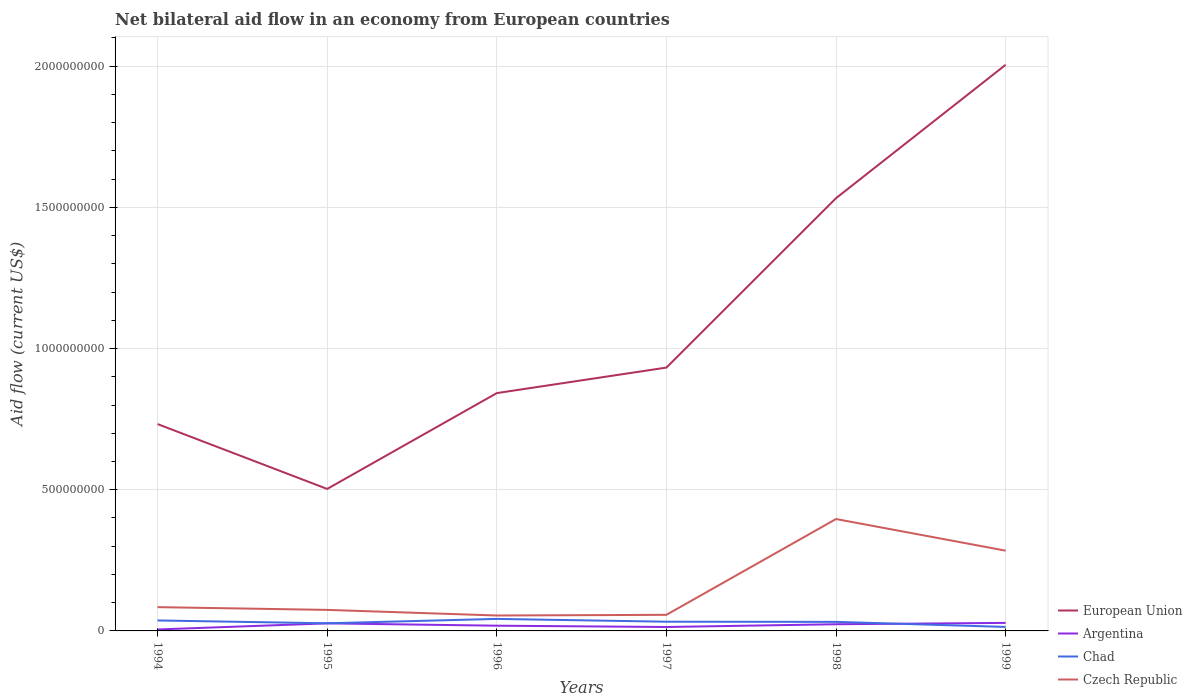How many different coloured lines are there?
Give a very brief answer. 4. Does the line corresponding to European Union intersect with the line corresponding to Czech Republic?
Give a very brief answer. No. Across all years, what is the maximum net bilateral aid flow in Argentina?
Give a very brief answer. 5.17e+06. In which year was the net bilateral aid flow in Czech Republic maximum?
Provide a succinct answer. 1996. What is the total net bilateral aid flow in Chad in the graph?
Keep it short and to the point. 9.90e+06. What is the difference between the highest and the second highest net bilateral aid flow in European Union?
Your answer should be compact. 1.50e+09. How many lines are there?
Ensure brevity in your answer.  4. What is the difference between two consecutive major ticks on the Y-axis?
Provide a succinct answer. 5.00e+08. Does the graph contain grids?
Give a very brief answer. Yes. How many legend labels are there?
Provide a succinct answer. 4. How are the legend labels stacked?
Your response must be concise. Vertical. What is the title of the graph?
Provide a short and direct response. Net bilateral aid flow in an economy from European countries. What is the label or title of the Y-axis?
Your answer should be compact. Aid flow (current US$). What is the Aid flow (current US$) in European Union in 1994?
Your response must be concise. 7.33e+08. What is the Aid flow (current US$) in Argentina in 1994?
Offer a very short reply. 5.17e+06. What is the Aid flow (current US$) of Chad in 1994?
Make the answer very short. 3.71e+07. What is the Aid flow (current US$) of Czech Republic in 1994?
Provide a short and direct response. 8.42e+07. What is the Aid flow (current US$) of European Union in 1995?
Offer a very short reply. 5.03e+08. What is the Aid flow (current US$) in Argentina in 1995?
Provide a short and direct response. 2.68e+07. What is the Aid flow (current US$) of Chad in 1995?
Your response must be concise. 2.70e+07. What is the Aid flow (current US$) of Czech Republic in 1995?
Provide a succinct answer. 7.45e+07. What is the Aid flow (current US$) in European Union in 1996?
Offer a very short reply. 8.42e+08. What is the Aid flow (current US$) in Argentina in 1996?
Your answer should be very brief. 1.85e+07. What is the Aid flow (current US$) of Chad in 1996?
Your response must be concise. 4.26e+07. What is the Aid flow (current US$) of Czech Republic in 1996?
Provide a short and direct response. 5.46e+07. What is the Aid flow (current US$) in European Union in 1997?
Provide a short and direct response. 9.33e+08. What is the Aid flow (current US$) of Argentina in 1997?
Your answer should be compact. 1.39e+07. What is the Aid flow (current US$) in Chad in 1997?
Offer a very short reply. 3.27e+07. What is the Aid flow (current US$) in Czech Republic in 1997?
Provide a succinct answer. 5.70e+07. What is the Aid flow (current US$) in European Union in 1998?
Your response must be concise. 1.53e+09. What is the Aid flow (current US$) of Argentina in 1998?
Offer a terse response. 2.37e+07. What is the Aid flow (current US$) of Chad in 1998?
Your answer should be compact. 3.21e+07. What is the Aid flow (current US$) in Czech Republic in 1998?
Give a very brief answer. 3.96e+08. What is the Aid flow (current US$) of European Union in 1999?
Offer a terse response. 2.01e+09. What is the Aid flow (current US$) of Argentina in 1999?
Make the answer very short. 2.84e+07. What is the Aid flow (current US$) in Chad in 1999?
Your answer should be very brief. 1.42e+07. What is the Aid flow (current US$) of Czech Republic in 1999?
Provide a short and direct response. 2.84e+08. Across all years, what is the maximum Aid flow (current US$) in European Union?
Give a very brief answer. 2.01e+09. Across all years, what is the maximum Aid flow (current US$) of Argentina?
Give a very brief answer. 2.84e+07. Across all years, what is the maximum Aid flow (current US$) in Chad?
Your answer should be compact. 4.26e+07. Across all years, what is the maximum Aid flow (current US$) in Czech Republic?
Your response must be concise. 3.96e+08. Across all years, what is the minimum Aid flow (current US$) in European Union?
Ensure brevity in your answer.  5.03e+08. Across all years, what is the minimum Aid flow (current US$) of Argentina?
Your response must be concise. 5.17e+06. Across all years, what is the minimum Aid flow (current US$) in Chad?
Provide a short and direct response. 1.42e+07. Across all years, what is the minimum Aid flow (current US$) in Czech Republic?
Offer a terse response. 5.46e+07. What is the total Aid flow (current US$) in European Union in the graph?
Offer a terse response. 6.55e+09. What is the total Aid flow (current US$) in Argentina in the graph?
Your answer should be compact. 1.16e+08. What is the total Aid flow (current US$) of Chad in the graph?
Your answer should be compact. 1.86e+08. What is the total Aid flow (current US$) in Czech Republic in the graph?
Provide a succinct answer. 9.51e+08. What is the difference between the Aid flow (current US$) of European Union in 1994 and that in 1995?
Provide a short and direct response. 2.30e+08. What is the difference between the Aid flow (current US$) of Argentina in 1994 and that in 1995?
Offer a very short reply. -2.16e+07. What is the difference between the Aid flow (current US$) in Chad in 1994 and that in 1995?
Give a very brief answer. 1.01e+07. What is the difference between the Aid flow (current US$) of Czech Republic in 1994 and that in 1995?
Provide a succinct answer. 9.75e+06. What is the difference between the Aid flow (current US$) in European Union in 1994 and that in 1996?
Ensure brevity in your answer.  -1.10e+08. What is the difference between the Aid flow (current US$) in Argentina in 1994 and that in 1996?
Ensure brevity in your answer.  -1.33e+07. What is the difference between the Aid flow (current US$) of Chad in 1994 and that in 1996?
Offer a very short reply. -5.50e+06. What is the difference between the Aid flow (current US$) in Czech Republic in 1994 and that in 1996?
Provide a short and direct response. 2.96e+07. What is the difference between the Aid flow (current US$) in European Union in 1994 and that in 1997?
Provide a short and direct response. -2.00e+08. What is the difference between the Aid flow (current US$) in Argentina in 1994 and that in 1997?
Provide a succinct answer. -8.72e+06. What is the difference between the Aid flow (current US$) of Chad in 1994 and that in 1997?
Keep it short and to the point. 4.40e+06. What is the difference between the Aid flow (current US$) in Czech Republic in 1994 and that in 1997?
Keep it short and to the point. 2.72e+07. What is the difference between the Aid flow (current US$) in European Union in 1994 and that in 1998?
Ensure brevity in your answer.  -8.00e+08. What is the difference between the Aid flow (current US$) of Argentina in 1994 and that in 1998?
Your response must be concise. -1.85e+07. What is the difference between the Aid flow (current US$) of Chad in 1994 and that in 1998?
Give a very brief answer. 5.01e+06. What is the difference between the Aid flow (current US$) of Czech Republic in 1994 and that in 1998?
Offer a very short reply. -3.12e+08. What is the difference between the Aid flow (current US$) of European Union in 1994 and that in 1999?
Keep it short and to the point. -1.27e+09. What is the difference between the Aid flow (current US$) of Argentina in 1994 and that in 1999?
Offer a terse response. -2.33e+07. What is the difference between the Aid flow (current US$) in Chad in 1994 and that in 1999?
Offer a terse response. 2.29e+07. What is the difference between the Aid flow (current US$) in Czech Republic in 1994 and that in 1999?
Make the answer very short. -2.00e+08. What is the difference between the Aid flow (current US$) of European Union in 1995 and that in 1996?
Provide a succinct answer. -3.39e+08. What is the difference between the Aid flow (current US$) in Argentina in 1995 and that in 1996?
Make the answer very short. 8.29e+06. What is the difference between the Aid flow (current US$) in Chad in 1995 and that in 1996?
Give a very brief answer. -1.56e+07. What is the difference between the Aid flow (current US$) in Czech Republic in 1995 and that in 1996?
Provide a short and direct response. 1.99e+07. What is the difference between the Aid flow (current US$) in European Union in 1995 and that in 1997?
Provide a succinct answer. -4.30e+08. What is the difference between the Aid flow (current US$) in Argentina in 1995 and that in 1997?
Your response must be concise. 1.29e+07. What is the difference between the Aid flow (current US$) in Chad in 1995 and that in 1997?
Your response must be concise. -5.67e+06. What is the difference between the Aid flow (current US$) of Czech Republic in 1995 and that in 1997?
Provide a short and direct response. 1.75e+07. What is the difference between the Aid flow (current US$) of European Union in 1995 and that in 1998?
Ensure brevity in your answer.  -1.03e+09. What is the difference between the Aid flow (current US$) of Argentina in 1995 and that in 1998?
Your answer should be compact. 3.12e+06. What is the difference between the Aid flow (current US$) of Chad in 1995 and that in 1998?
Give a very brief answer. -5.06e+06. What is the difference between the Aid flow (current US$) of Czech Republic in 1995 and that in 1998?
Provide a short and direct response. -3.22e+08. What is the difference between the Aid flow (current US$) in European Union in 1995 and that in 1999?
Provide a short and direct response. -1.50e+09. What is the difference between the Aid flow (current US$) in Argentina in 1995 and that in 1999?
Provide a short and direct response. -1.63e+06. What is the difference between the Aid flow (current US$) of Chad in 1995 and that in 1999?
Your answer should be very brief. 1.28e+07. What is the difference between the Aid flow (current US$) of Czech Republic in 1995 and that in 1999?
Offer a terse response. -2.10e+08. What is the difference between the Aid flow (current US$) of European Union in 1996 and that in 1997?
Make the answer very short. -9.04e+07. What is the difference between the Aid flow (current US$) in Argentina in 1996 and that in 1997?
Provide a succinct answer. 4.62e+06. What is the difference between the Aid flow (current US$) of Chad in 1996 and that in 1997?
Your response must be concise. 9.90e+06. What is the difference between the Aid flow (current US$) of Czech Republic in 1996 and that in 1997?
Give a very brief answer. -2.37e+06. What is the difference between the Aid flow (current US$) in European Union in 1996 and that in 1998?
Your response must be concise. -6.90e+08. What is the difference between the Aid flow (current US$) of Argentina in 1996 and that in 1998?
Offer a terse response. -5.17e+06. What is the difference between the Aid flow (current US$) of Chad in 1996 and that in 1998?
Your answer should be compact. 1.05e+07. What is the difference between the Aid flow (current US$) in Czech Republic in 1996 and that in 1998?
Your response must be concise. -3.42e+08. What is the difference between the Aid flow (current US$) in European Union in 1996 and that in 1999?
Your response must be concise. -1.16e+09. What is the difference between the Aid flow (current US$) of Argentina in 1996 and that in 1999?
Ensure brevity in your answer.  -9.92e+06. What is the difference between the Aid flow (current US$) in Chad in 1996 and that in 1999?
Your answer should be very brief. 2.84e+07. What is the difference between the Aid flow (current US$) in Czech Republic in 1996 and that in 1999?
Offer a terse response. -2.30e+08. What is the difference between the Aid flow (current US$) in European Union in 1997 and that in 1998?
Your response must be concise. -6.00e+08. What is the difference between the Aid flow (current US$) of Argentina in 1997 and that in 1998?
Keep it short and to the point. -9.79e+06. What is the difference between the Aid flow (current US$) in Chad in 1997 and that in 1998?
Ensure brevity in your answer.  6.10e+05. What is the difference between the Aid flow (current US$) of Czech Republic in 1997 and that in 1998?
Your response must be concise. -3.39e+08. What is the difference between the Aid flow (current US$) of European Union in 1997 and that in 1999?
Make the answer very short. -1.07e+09. What is the difference between the Aid flow (current US$) of Argentina in 1997 and that in 1999?
Ensure brevity in your answer.  -1.45e+07. What is the difference between the Aid flow (current US$) in Chad in 1997 and that in 1999?
Keep it short and to the point. 1.85e+07. What is the difference between the Aid flow (current US$) in Czech Republic in 1997 and that in 1999?
Give a very brief answer. -2.27e+08. What is the difference between the Aid flow (current US$) in European Union in 1998 and that in 1999?
Give a very brief answer. -4.72e+08. What is the difference between the Aid flow (current US$) in Argentina in 1998 and that in 1999?
Make the answer very short. -4.75e+06. What is the difference between the Aid flow (current US$) of Chad in 1998 and that in 1999?
Offer a very short reply. 1.79e+07. What is the difference between the Aid flow (current US$) of Czech Republic in 1998 and that in 1999?
Ensure brevity in your answer.  1.12e+08. What is the difference between the Aid flow (current US$) of European Union in 1994 and the Aid flow (current US$) of Argentina in 1995?
Offer a terse response. 7.06e+08. What is the difference between the Aid flow (current US$) of European Union in 1994 and the Aid flow (current US$) of Chad in 1995?
Provide a short and direct response. 7.06e+08. What is the difference between the Aid flow (current US$) in European Union in 1994 and the Aid flow (current US$) in Czech Republic in 1995?
Your answer should be compact. 6.58e+08. What is the difference between the Aid flow (current US$) in Argentina in 1994 and the Aid flow (current US$) in Chad in 1995?
Provide a succinct answer. -2.18e+07. What is the difference between the Aid flow (current US$) of Argentina in 1994 and the Aid flow (current US$) of Czech Republic in 1995?
Offer a very short reply. -6.93e+07. What is the difference between the Aid flow (current US$) of Chad in 1994 and the Aid flow (current US$) of Czech Republic in 1995?
Your response must be concise. -3.74e+07. What is the difference between the Aid flow (current US$) in European Union in 1994 and the Aid flow (current US$) in Argentina in 1996?
Ensure brevity in your answer.  7.14e+08. What is the difference between the Aid flow (current US$) of European Union in 1994 and the Aid flow (current US$) of Chad in 1996?
Ensure brevity in your answer.  6.90e+08. What is the difference between the Aid flow (current US$) of European Union in 1994 and the Aid flow (current US$) of Czech Republic in 1996?
Give a very brief answer. 6.78e+08. What is the difference between the Aid flow (current US$) of Argentina in 1994 and the Aid flow (current US$) of Chad in 1996?
Provide a short and direct response. -3.74e+07. What is the difference between the Aid flow (current US$) of Argentina in 1994 and the Aid flow (current US$) of Czech Republic in 1996?
Keep it short and to the point. -4.94e+07. What is the difference between the Aid flow (current US$) of Chad in 1994 and the Aid flow (current US$) of Czech Republic in 1996?
Make the answer very short. -1.76e+07. What is the difference between the Aid flow (current US$) of European Union in 1994 and the Aid flow (current US$) of Argentina in 1997?
Provide a short and direct response. 7.19e+08. What is the difference between the Aid flow (current US$) of European Union in 1994 and the Aid flow (current US$) of Chad in 1997?
Give a very brief answer. 7.00e+08. What is the difference between the Aid flow (current US$) of European Union in 1994 and the Aid flow (current US$) of Czech Republic in 1997?
Give a very brief answer. 6.76e+08. What is the difference between the Aid flow (current US$) of Argentina in 1994 and the Aid flow (current US$) of Chad in 1997?
Provide a short and direct response. -2.75e+07. What is the difference between the Aid flow (current US$) in Argentina in 1994 and the Aid flow (current US$) in Czech Republic in 1997?
Your response must be concise. -5.18e+07. What is the difference between the Aid flow (current US$) in Chad in 1994 and the Aid flow (current US$) in Czech Republic in 1997?
Give a very brief answer. -1.99e+07. What is the difference between the Aid flow (current US$) in European Union in 1994 and the Aid flow (current US$) in Argentina in 1998?
Your answer should be compact. 7.09e+08. What is the difference between the Aid flow (current US$) of European Union in 1994 and the Aid flow (current US$) of Chad in 1998?
Your response must be concise. 7.01e+08. What is the difference between the Aid flow (current US$) of European Union in 1994 and the Aid flow (current US$) of Czech Republic in 1998?
Your answer should be compact. 3.36e+08. What is the difference between the Aid flow (current US$) in Argentina in 1994 and the Aid flow (current US$) in Chad in 1998?
Offer a terse response. -2.69e+07. What is the difference between the Aid flow (current US$) in Argentina in 1994 and the Aid flow (current US$) in Czech Republic in 1998?
Offer a very short reply. -3.91e+08. What is the difference between the Aid flow (current US$) in Chad in 1994 and the Aid flow (current US$) in Czech Republic in 1998?
Give a very brief answer. -3.59e+08. What is the difference between the Aid flow (current US$) of European Union in 1994 and the Aid flow (current US$) of Argentina in 1999?
Give a very brief answer. 7.04e+08. What is the difference between the Aid flow (current US$) in European Union in 1994 and the Aid flow (current US$) in Chad in 1999?
Give a very brief answer. 7.18e+08. What is the difference between the Aid flow (current US$) in European Union in 1994 and the Aid flow (current US$) in Czech Republic in 1999?
Ensure brevity in your answer.  4.48e+08. What is the difference between the Aid flow (current US$) of Argentina in 1994 and the Aid flow (current US$) of Chad in 1999?
Your answer should be compact. -8.98e+06. What is the difference between the Aid flow (current US$) in Argentina in 1994 and the Aid flow (current US$) in Czech Republic in 1999?
Offer a terse response. -2.79e+08. What is the difference between the Aid flow (current US$) of Chad in 1994 and the Aid flow (current US$) of Czech Republic in 1999?
Offer a very short reply. -2.47e+08. What is the difference between the Aid flow (current US$) in European Union in 1995 and the Aid flow (current US$) in Argentina in 1996?
Provide a short and direct response. 4.84e+08. What is the difference between the Aid flow (current US$) of European Union in 1995 and the Aid flow (current US$) of Chad in 1996?
Your answer should be very brief. 4.60e+08. What is the difference between the Aid flow (current US$) of European Union in 1995 and the Aid flow (current US$) of Czech Republic in 1996?
Offer a terse response. 4.48e+08. What is the difference between the Aid flow (current US$) in Argentina in 1995 and the Aid flow (current US$) in Chad in 1996?
Provide a short and direct response. -1.58e+07. What is the difference between the Aid flow (current US$) in Argentina in 1995 and the Aid flow (current US$) in Czech Republic in 1996?
Your answer should be very brief. -2.78e+07. What is the difference between the Aid flow (current US$) in Chad in 1995 and the Aid flow (current US$) in Czech Republic in 1996?
Give a very brief answer. -2.76e+07. What is the difference between the Aid flow (current US$) of European Union in 1995 and the Aid flow (current US$) of Argentina in 1997?
Provide a short and direct response. 4.89e+08. What is the difference between the Aid flow (current US$) in European Union in 1995 and the Aid flow (current US$) in Chad in 1997?
Provide a short and direct response. 4.70e+08. What is the difference between the Aid flow (current US$) in European Union in 1995 and the Aid flow (current US$) in Czech Republic in 1997?
Your response must be concise. 4.46e+08. What is the difference between the Aid flow (current US$) in Argentina in 1995 and the Aid flow (current US$) in Chad in 1997?
Your answer should be very brief. -5.87e+06. What is the difference between the Aid flow (current US$) of Argentina in 1995 and the Aid flow (current US$) of Czech Republic in 1997?
Your answer should be very brief. -3.02e+07. What is the difference between the Aid flow (current US$) in Chad in 1995 and the Aid flow (current US$) in Czech Republic in 1997?
Your answer should be compact. -3.00e+07. What is the difference between the Aid flow (current US$) in European Union in 1995 and the Aid flow (current US$) in Argentina in 1998?
Make the answer very short. 4.79e+08. What is the difference between the Aid flow (current US$) of European Union in 1995 and the Aid flow (current US$) of Chad in 1998?
Your answer should be very brief. 4.71e+08. What is the difference between the Aid flow (current US$) of European Union in 1995 and the Aid flow (current US$) of Czech Republic in 1998?
Provide a succinct answer. 1.07e+08. What is the difference between the Aid flow (current US$) in Argentina in 1995 and the Aid flow (current US$) in Chad in 1998?
Make the answer very short. -5.26e+06. What is the difference between the Aid flow (current US$) in Argentina in 1995 and the Aid flow (current US$) in Czech Republic in 1998?
Provide a short and direct response. -3.69e+08. What is the difference between the Aid flow (current US$) of Chad in 1995 and the Aid flow (current US$) of Czech Republic in 1998?
Offer a terse response. -3.69e+08. What is the difference between the Aid flow (current US$) of European Union in 1995 and the Aid flow (current US$) of Argentina in 1999?
Make the answer very short. 4.74e+08. What is the difference between the Aid flow (current US$) of European Union in 1995 and the Aid flow (current US$) of Chad in 1999?
Your answer should be compact. 4.89e+08. What is the difference between the Aid flow (current US$) in European Union in 1995 and the Aid flow (current US$) in Czech Republic in 1999?
Keep it short and to the point. 2.19e+08. What is the difference between the Aid flow (current US$) in Argentina in 1995 and the Aid flow (current US$) in Chad in 1999?
Provide a short and direct response. 1.26e+07. What is the difference between the Aid flow (current US$) of Argentina in 1995 and the Aid flow (current US$) of Czech Republic in 1999?
Your answer should be very brief. -2.57e+08. What is the difference between the Aid flow (current US$) of Chad in 1995 and the Aid flow (current US$) of Czech Republic in 1999?
Give a very brief answer. -2.57e+08. What is the difference between the Aid flow (current US$) in European Union in 1996 and the Aid flow (current US$) in Argentina in 1997?
Give a very brief answer. 8.28e+08. What is the difference between the Aid flow (current US$) in European Union in 1996 and the Aid flow (current US$) in Chad in 1997?
Your answer should be compact. 8.10e+08. What is the difference between the Aid flow (current US$) in European Union in 1996 and the Aid flow (current US$) in Czech Republic in 1997?
Offer a very short reply. 7.85e+08. What is the difference between the Aid flow (current US$) in Argentina in 1996 and the Aid flow (current US$) in Chad in 1997?
Ensure brevity in your answer.  -1.42e+07. What is the difference between the Aid flow (current US$) in Argentina in 1996 and the Aid flow (current US$) in Czech Republic in 1997?
Provide a short and direct response. -3.85e+07. What is the difference between the Aid flow (current US$) of Chad in 1996 and the Aid flow (current US$) of Czech Republic in 1997?
Your answer should be very brief. -1.44e+07. What is the difference between the Aid flow (current US$) of European Union in 1996 and the Aid flow (current US$) of Argentina in 1998?
Provide a succinct answer. 8.19e+08. What is the difference between the Aid flow (current US$) of European Union in 1996 and the Aid flow (current US$) of Chad in 1998?
Your answer should be compact. 8.10e+08. What is the difference between the Aid flow (current US$) of European Union in 1996 and the Aid flow (current US$) of Czech Republic in 1998?
Ensure brevity in your answer.  4.46e+08. What is the difference between the Aid flow (current US$) of Argentina in 1996 and the Aid flow (current US$) of Chad in 1998?
Your response must be concise. -1.36e+07. What is the difference between the Aid flow (current US$) of Argentina in 1996 and the Aid flow (current US$) of Czech Republic in 1998?
Ensure brevity in your answer.  -3.78e+08. What is the difference between the Aid flow (current US$) in Chad in 1996 and the Aid flow (current US$) in Czech Republic in 1998?
Offer a very short reply. -3.54e+08. What is the difference between the Aid flow (current US$) in European Union in 1996 and the Aid flow (current US$) in Argentina in 1999?
Keep it short and to the point. 8.14e+08. What is the difference between the Aid flow (current US$) in European Union in 1996 and the Aid flow (current US$) in Chad in 1999?
Keep it short and to the point. 8.28e+08. What is the difference between the Aid flow (current US$) in European Union in 1996 and the Aid flow (current US$) in Czech Republic in 1999?
Keep it short and to the point. 5.58e+08. What is the difference between the Aid flow (current US$) in Argentina in 1996 and the Aid flow (current US$) in Chad in 1999?
Give a very brief answer. 4.36e+06. What is the difference between the Aid flow (current US$) in Argentina in 1996 and the Aid flow (current US$) in Czech Republic in 1999?
Provide a short and direct response. -2.66e+08. What is the difference between the Aid flow (current US$) of Chad in 1996 and the Aid flow (current US$) of Czech Republic in 1999?
Make the answer very short. -2.42e+08. What is the difference between the Aid flow (current US$) of European Union in 1997 and the Aid flow (current US$) of Argentina in 1998?
Provide a succinct answer. 9.09e+08. What is the difference between the Aid flow (current US$) in European Union in 1997 and the Aid flow (current US$) in Chad in 1998?
Keep it short and to the point. 9.01e+08. What is the difference between the Aid flow (current US$) in European Union in 1997 and the Aid flow (current US$) in Czech Republic in 1998?
Your response must be concise. 5.36e+08. What is the difference between the Aid flow (current US$) in Argentina in 1997 and the Aid flow (current US$) in Chad in 1998?
Offer a terse response. -1.82e+07. What is the difference between the Aid flow (current US$) of Argentina in 1997 and the Aid flow (current US$) of Czech Republic in 1998?
Give a very brief answer. -3.82e+08. What is the difference between the Aid flow (current US$) in Chad in 1997 and the Aid flow (current US$) in Czech Republic in 1998?
Give a very brief answer. -3.64e+08. What is the difference between the Aid flow (current US$) in European Union in 1997 and the Aid flow (current US$) in Argentina in 1999?
Ensure brevity in your answer.  9.04e+08. What is the difference between the Aid flow (current US$) of European Union in 1997 and the Aid flow (current US$) of Chad in 1999?
Keep it short and to the point. 9.19e+08. What is the difference between the Aid flow (current US$) of European Union in 1997 and the Aid flow (current US$) of Czech Republic in 1999?
Offer a terse response. 6.48e+08. What is the difference between the Aid flow (current US$) in Argentina in 1997 and the Aid flow (current US$) in Czech Republic in 1999?
Keep it short and to the point. -2.70e+08. What is the difference between the Aid flow (current US$) in Chad in 1997 and the Aid flow (current US$) in Czech Republic in 1999?
Make the answer very short. -2.52e+08. What is the difference between the Aid flow (current US$) in European Union in 1998 and the Aid flow (current US$) in Argentina in 1999?
Ensure brevity in your answer.  1.50e+09. What is the difference between the Aid flow (current US$) of European Union in 1998 and the Aid flow (current US$) of Chad in 1999?
Provide a short and direct response. 1.52e+09. What is the difference between the Aid flow (current US$) in European Union in 1998 and the Aid flow (current US$) in Czech Republic in 1999?
Offer a very short reply. 1.25e+09. What is the difference between the Aid flow (current US$) in Argentina in 1998 and the Aid flow (current US$) in Chad in 1999?
Make the answer very short. 9.53e+06. What is the difference between the Aid flow (current US$) in Argentina in 1998 and the Aid flow (current US$) in Czech Republic in 1999?
Keep it short and to the point. -2.61e+08. What is the difference between the Aid flow (current US$) of Chad in 1998 and the Aid flow (current US$) of Czech Republic in 1999?
Provide a succinct answer. -2.52e+08. What is the average Aid flow (current US$) of European Union per year?
Ensure brevity in your answer.  1.09e+09. What is the average Aid flow (current US$) in Argentina per year?
Give a very brief answer. 1.94e+07. What is the average Aid flow (current US$) in Chad per year?
Make the answer very short. 3.09e+07. What is the average Aid flow (current US$) of Czech Republic per year?
Offer a terse response. 1.58e+08. In the year 1994, what is the difference between the Aid flow (current US$) in European Union and Aid flow (current US$) in Argentina?
Offer a terse response. 7.27e+08. In the year 1994, what is the difference between the Aid flow (current US$) in European Union and Aid flow (current US$) in Chad?
Offer a terse response. 6.96e+08. In the year 1994, what is the difference between the Aid flow (current US$) in European Union and Aid flow (current US$) in Czech Republic?
Ensure brevity in your answer.  6.48e+08. In the year 1994, what is the difference between the Aid flow (current US$) of Argentina and Aid flow (current US$) of Chad?
Give a very brief answer. -3.19e+07. In the year 1994, what is the difference between the Aid flow (current US$) of Argentina and Aid flow (current US$) of Czech Republic?
Provide a short and direct response. -7.91e+07. In the year 1994, what is the difference between the Aid flow (current US$) in Chad and Aid flow (current US$) in Czech Republic?
Offer a very short reply. -4.72e+07. In the year 1995, what is the difference between the Aid flow (current US$) in European Union and Aid flow (current US$) in Argentina?
Ensure brevity in your answer.  4.76e+08. In the year 1995, what is the difference between the Aid flow (current US$) of European Union and Aid flow (current US$) of Chad?
Ensure brevity in your answer.  4.76e+08. In the year 1995, what is the difference between the Aid flow (current US$) in European Union and Aid flow (current US$) in Czech Republic?
Offer a very short reply. 4.28e+08. In the year 1995, what is the difference between the Aid flow (current US$) in Argentina and Aid flow (current US$) in Czech Republic?
Offer a very short reply. -4.77e+07. In the year 1995, what is the difference between the Aid flow (current US$) in Chad and Aid flow (current US$) in Czech Republic?
Ensure brevity in your answer.  -4.75e+07. In the year 1996, what is the difference between the Aid flow (current US$) of European Union and Aid flow (current US$) of Argentina?
Offer a terse response. 8.24e+08. In the year 1996, what is the difference between the Aid flow (current US$) in European Union and Aid flow (current US$) in Chad?
Offer a very short reply. 8.00e+08. In the year 1996, what is the difference between the Aid flow (current US$) of European Union and Aid flow (current US$) of Czech Republic?
Keep it short and to the point. 7.88e+08. In the year 1996, what is the difference between the Aid flow (current US$) in Argentina and Aid flow (current US$) in Chad?
Provide a succinct answer. -2.41e+07. In the year 1996, what is the difference between the Aid flow (current US$) of Argentina and Aid flow (current US$) of Czech Republic?
Keep it short and to the point. -3.61e+07. In the year 1996, what is the difference between the Aid flow (current US$) in Chad and Aid flow (current US$) in Czech Republic?
Your response must be concise. -1.20e+07. In the year 1997, what is the difference between the Aid flow (current US$) of European Union and Aid flow (current US$) of Argentina?
Give a very brief answer. 9.19e+08. In the year 1997, what is the difference between the Aid flow (current US$) in European Union and Aid flow (current US$) in Chad?
Provide a succinct answer. 9.00e+08. In the year 1997, what is the difference between the Aid flow (current US$) in European Union and Aid flow (current US$) in Czech Republic?
Provide a short and direct response. 8.76e+08. In the year 1997, what is the difference between the Aid flow (current US$) of Argentina and Aid flow (current US$) of Chad?
Offer a very short reply. -1.88e+07. In the year 1997, what is the difference between the Aid flow (current US$) in Argentina and Aid flow (current US$) in Czech Republic?
Offer a very short reply. -4.31e+07. In the year 1997, what is the difference between the Aid flow (current US$) of Chad and Aid flow (current US$) of Czech Republic?
Your answer should be compact. -2.43e+07. In the year 1998, what is the difference between the Aid flow (current US$) of European Union and Aid flow (current US$) of Argentina?
Offer a terse response. 1.51e+09. In the year 1998, what is the difference between the Aid flow (current US$) in European Union and Aid flow (current US$) in Chad?
Ensure brevity in your answer.  1.50e+09. In the year 1998, what is the difference between the Aid flow (current US$) of European Union and Aid flow (current US$) of Czech Republic?
Your response must be concise. 1.14e+09. In the year 1998, what is the difference between the Aid flow (current US$) in Argentina and Aid flow (current US$) in Chad?
Provide a succinct answer. -8.38e+06. In the year 1998, what is the difference between the Aid flow (current US$) of Argentina and Aid flow (current US$) of Czech Republic?
Keep it short and to the point. -3.73e+08. In the year 1998, what is the difference between the Aid flow (current US$) in Chad and Aid flow (current US$) in Czech Republic?
Your response must be concise. -3.64e+08. In the year 1999, what is the difference between the Aid flow (current US$) of European Union and Aid flow (current US$) of Argentina?
Ensure brevity in your answer.  1.98e+09. In the year 1999, what is the difference between the Aid flow (current US$) of European Union and Aid flow (current US$) of Chad?
Offer a terse response. 1.99e+09. In the year 1999, what is the difference between the Aid flow (current US$) of European Union and Aid flow (current US$) of Czech Republic?
Your answer should be compact. 1.72e+09. In the year 1999, what is the difference between the Aid flow (current US$) in Argentina and Aid flow (current US$) in Chad?
Ensure brevity in your answer.  1.43e+07. In the year 1999, what is the difference between the Aid flow (current US$) of Argentina and Aid flow (current US$) of Czech Republic?
Your answer should be compact. -2.56e+08. In the year 1999, what is the difference between the Aid flow (current US$) of Chad and Aid flow (current US$) of Czech Republic?
Ensure brevity in your answer.  -2.70e+08. What is the ratio of the Aid flow (current US$) in European Union in 1994 to that in 1995?
Keep it short and to the point. 1.46. What is the ratio of the Aid flow (current US$) in Argentina in 1994 to that in 1995?
Ensure brevity in your answer.  0.19. What is the ratio of the Aid flow (current US$) in Chad in 1994 to that in 1995?
Keep it short and to the point. 1.37. What is the ratio of the Aid flow (current US$) of Czech Republic in 1994 to that in 1995?
Provide a succinct answer. 1.13. What is the ratio of the Aid flow (current US$) of European Union in 1994 to that in 1996?
Give a very brief answer. 0.87. What is the ratio of the Aid flow (current US$) of Argentina in 1994 to that in 1996?
Keep it short and to the point. 0.28. What is the ratio of the Aid flow (current US$) in Chad in 1994 to that in 1996?
Provide a short and direct response. 0.87. What is the ratio of the Aid flow (current US$) of Czech Republic in 1994 to that in 1996?
Offer a terse response. 1.54. What is the ratio of the Aid flow (current US$) in European Union in 1994 to that in 1997?
Offer a very short reply. 0.79. What is the ratio of the Aid flow (current US$) of Argentina in 1994 to that in 1997?
Keep it short and to the point. 0.37. What is the ratio of the Aid flow (current US$) in Chad in 1994 to that in 1997?
Keep it short and to the point. 1.13. What is the ratio of the Aid flow (current US$) of Czech Republic in 1994 to that in 1997?
Give a very brief answer. 1.48. What is the ratio of the Aid flow (current US$) of European Union in 1994 to that in 1998?
Your answer should be very brief. 0.48. What is the ratio of the Aid flow (current US$) of Argentina in 1994 to that in 1998?
Your response must be concise. 0.22. What is the ratio of the Aid flow (current US$) in Chad in 1994 to that in 1998?
Provide a succinct answer. 1.16. What is the ratio of the Aid flow (current US$) of Czech Republic in 1994 to that in 1998?
Provide a short and direct response. 0.21. What is the ratio of the Aid flow (current US$) in European Union in 1994 to that in 1999?
Provide a succinct answer. 0.37. What is the ratio of the Aid flow (current US$) in Argentina in 1994 to that in 1999?
Ensure brevity in your answer.  0.18. What is the ratio of the Aid flow (current US$) in Chad in 1994 to that in 1999?
Your response must be concise. 2.62. What is the ratio of the Aid flow (current US$) in Czech Republic in 1994 to that in 1999?
Keep it short and to the point. 0.3. What is the ratio of the Aid flow (current US$) of European Union in 1995 to that in 1996?
Provide a short and direct response. 0.6. What is the ratio of the Aid flow (current US$) in Argentina in 1995 to that in 1996?
Your response must be concise. 1.45. What is the ratio of the Aid flow (current US$) of Chad in 1995 to that in 1996?
Offer a very short reply. 0.63. What is the ratio of the Aid flow (current US$) in Czech Republic in 1995 to that in 1996?
Offer a very short reply. 1.36. What is the ratio of the Aid flow (current US$) of European Union in 1995 to that in 1997?
Offer a very short reply. 0.54. What is the ratio of the Aid flow (current US$) of Argentina in 1995 to that in 1997?
Keep it short and to the point. 1.93. What is the ratio of the Aid flow (current US$) of Chad in 1995 to that in 1997?
Keep it short and to the point. 0.83. What is the ratio of the Aid flow (current US$) of Czech Republic in 1995 to that in 1997?
Provide a short and direct response. 1.31. What is the ratio of the Aid flow (current US$) of European Union in 1995 to that in 1998?
Offer a terse response. 0.33. What is the ratio of the Aid flow (current US$) in Argentina in 1995 to that in 1998?
Give a very brief answer. 1.13. What is the ratio of the Aid flow (current US$) of Chad in 1995 to that in 1998?
Provide a succinct answer. 0.84. What is the ratio of the Aid flow (current US$) in Czech Republic in 1995 to that in 1998?
Your answer should be very brief. 0.19. What is the ratio of the Aid flow (current US$) in European Union in 1995 to that in 1999?
Give a very brief answer. 0.25. What is the ratio of the Aid flow (current US$) in Argentina in 1995 to that in 1999?
Ensure brevity in your answer.  0.94. What is the ratio of the Aid flow (current US$) of Chad in 1995 to that in 1999?
Provide a succinct answer. 1.91. What is the ratio of the Aid flow (current US$) in Czech Republic in 1995 to that in 1999?
Make the answer very short. 0.26. What is the ratio of the Aid flow (current US$) in European Union in 1996 to that in 1997?
Offer a terse response. 0.9. What is the ratio of the Aid flow (current US$) of Argentina in 1996 to that in 1997?
Your answer should be very brief. 1.33. What is the ratio of the Aid flow (current US$) in Chad in 1996 to that in 1997?
Make the answer very short. 1.3. What is the ratio of the Aid flow (current US$) in Czech Republic in 1996 to that in 1997?
Provide a short and direct response. 0.96. What is the ratio of the Aid flow (current US$) in European Union in 1996 to that in 1998?
Provide a succinct answer. 0.55. What is the ratio of the Aid flow (current US$) in Argentina in 1996 to that in 1998?
Offer a terse response. 0.78. What is the ratio of the Aid flow (current US$) of Chad in 1996 to that in 1998?
Provide a short and direct response. 1.33. What is the ratio of the Aid flow (current US$) of Czech Republic in 1996 to that in 1998?
Give a very brief answer. 0.14. What is the ratio of the Aid flow (current US$) in European Union in 1996 to that in 1999?
Provide a short and direct response. 0.42. What is the ratio of the Aid flow (current US$) in Argentina in 1996 to that in 1999?
Ensure brevity in your answer.  0.65. What is the ratio of the Aid flow (current US$) in Chad in 1996 to that in 1999?
Your answer should be compact. 3.01. What is the ratio of the Aid flow (current US$) of Czech Republic in 1996 to that in 1999?
Ensure brevity in your answer.  0.19. What is the ratio of the Aid flow (current US$) in European Union in 1997 to that in 1998?
Offer a very short reply. 0.61. What is the ratio of the Aid flow (current US$) of Argentina in 1997 to that in 1998?
Give a very brief answer. 0.59. What is the ratio of the Aid flow (current US$) in Czech Republic in 1997 to that in 1998?
Your response must be concise. 0.14. What is the ratio of the Aid flow (current US$) in European Union in 1997 to that in 1999?
Make the answer very short. 0.47. What is the ratio of the Aid flow (current US$) of Argentina in 1997 to that in 1999?
Provide a succinct answer. 0.49. What is the ratio of the Aid flow (current US$) of Chad in 1997 to that in 1999?
Ensure brevity in your answer.  2.31. What is the ratio of the Aid flow (current US$) in Czech Republic in 1997 to that in 1999?
Give a very brief answer. 0.2. What is the ratio of the Aid flow (current US$) of European Union in 1998 to that in 1999?
Your response must be concise. 0.76. What is the ratio of the Aid flow (current US$) of Argentina in 1998 to that in 1999?
Make the answer very short. 0.83. What is the ratio of the Aid flow (current US$) in Chad in 1998 to that in 1999?
Provide a succinct answer. 2.27. What is the ratio of the Aid flow (current US$) in Czech Republic in 1998 to that in 1999?
Make the answer very short. 1.39. What is the difference between the highest and the second highest Aid flow (current US$) of European Union?
Your answer should be very brief. 4.72e+08. What is the difference between the highest and the second highest Aid flow (current US$) in Argentina?
Your answer should be very brief. 1.63e+06. What is the difference between the highest and the second highest Aid flow (current US$) in Chad?
Your answer should be very brief. 5.50e+06. What is the difference between the highest and the second highest Aid flow (current US$) in Czech Republic?
Keep it short and to the point. 1.12e+08. What is the difference between the highest and the lowest Aid flow (current US$) in European Union?
Ensure brevity in your answer.  1.50e+09. What is the difference between the highest and the lowest Aid flow (current US$) in Argentina?
Your answer should be compact. 2.33e+07. What is the difference between the highest and the lowest Aid flow (current US$) in Chad?
Give a very brief answer. 2.84e+07. What is the difference between the highest and the lowest Aid flow (current US$) of Czech Republic?
Provide a short and direct response. 3.42e+08. 